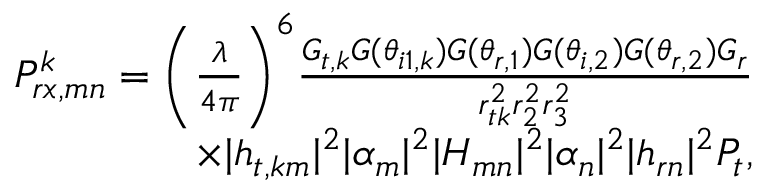<formula> <loc_0><loc_0><loc_500><loc_500>\begin{array} { r } { P _ { r x , m n } ^ { k } = \left ( \frac { \lambda } { 4 \pi } \right ) ^ { 6 } \frac { G _ { t , k } G ( \theta _ { i 1 , k } ) G ( \theta _ { r , 1 } ) G ( \theta _ { i , 2 } ) G ( \theta _ { r , 2 } ) G _ { r } } { r _ { t k } ^ { 2 } r _ { 2 } ^ { 2 } r _ { 3 } ^ { 2 } } } \\ { \times | { h } _ { t , k m } | ^ { 2 } | \alpha _ { m } | ^ { 2 } | H _ { m n } | ^ { 2 } | \alpha _ { n } | ^ { 2 } | { h } _ { r n } | ^ { 2 } P _ { t } , } \end{array}</formula> 